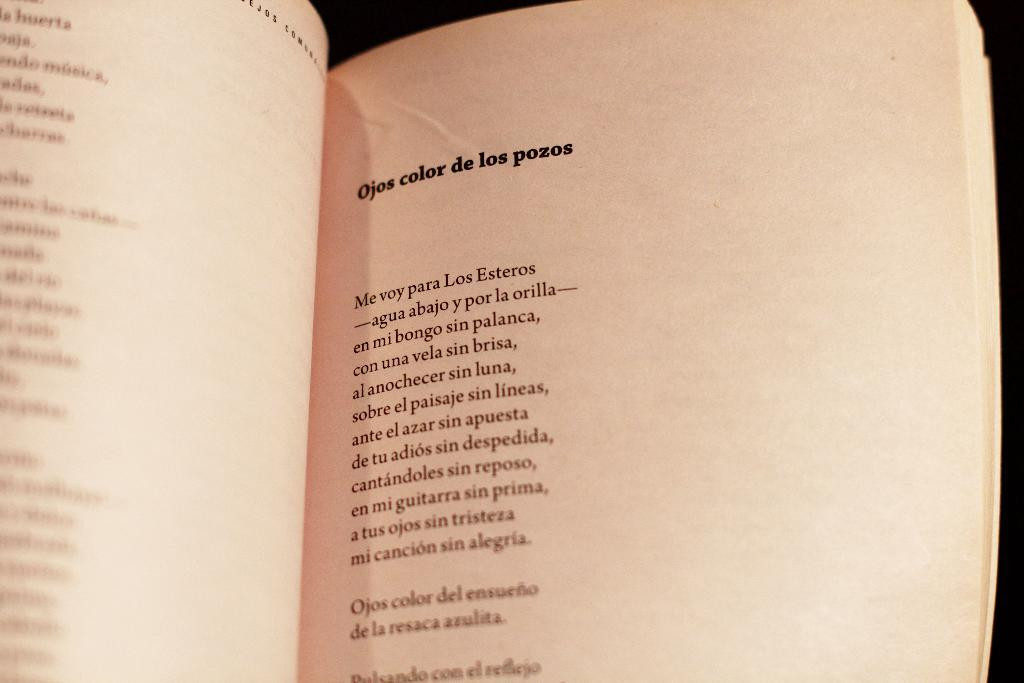<image>
Offer a succinct explanation of the picture presented. A book is open to a poem called Ojos color de los pozos. 